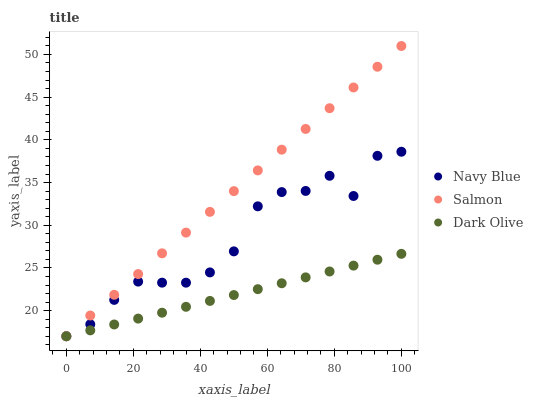Does Dark Olive have the minimum area under the curve?
Answer yes or no. Yes. Does Salmon have the maximum area under the curve?
Answer yes or no. Yes. Does Salmon have the minimum area under the curve?
Answer yes or no. No. Does Dark Olive have the maximum area under the curve?
Answer yes or no. No. Is Dark Olive the smoothest?
Answer yes or no. Yes. Is Navy Blue the roughest?
Answer yes or no. Yes. Is Salmon the smoothest?
Answer yes or no. No. Is Salmon the roughest?
Answer yes or no. No. Does Navy Blue have the lowest value?
Answer yes or no. Yes. Does Salmon have the highest value?
Answer yes or no. Yes. Does Dark Olive have the highest value?
Answer yes or no. No. Does Salmon intersect Dark Olive?
Answer yes or no. Yes. Is Salmon less than Dark Olive?
Answer yes or no. No. Is Salmon greater than Dark Olive?
Answer yes or no. No. 